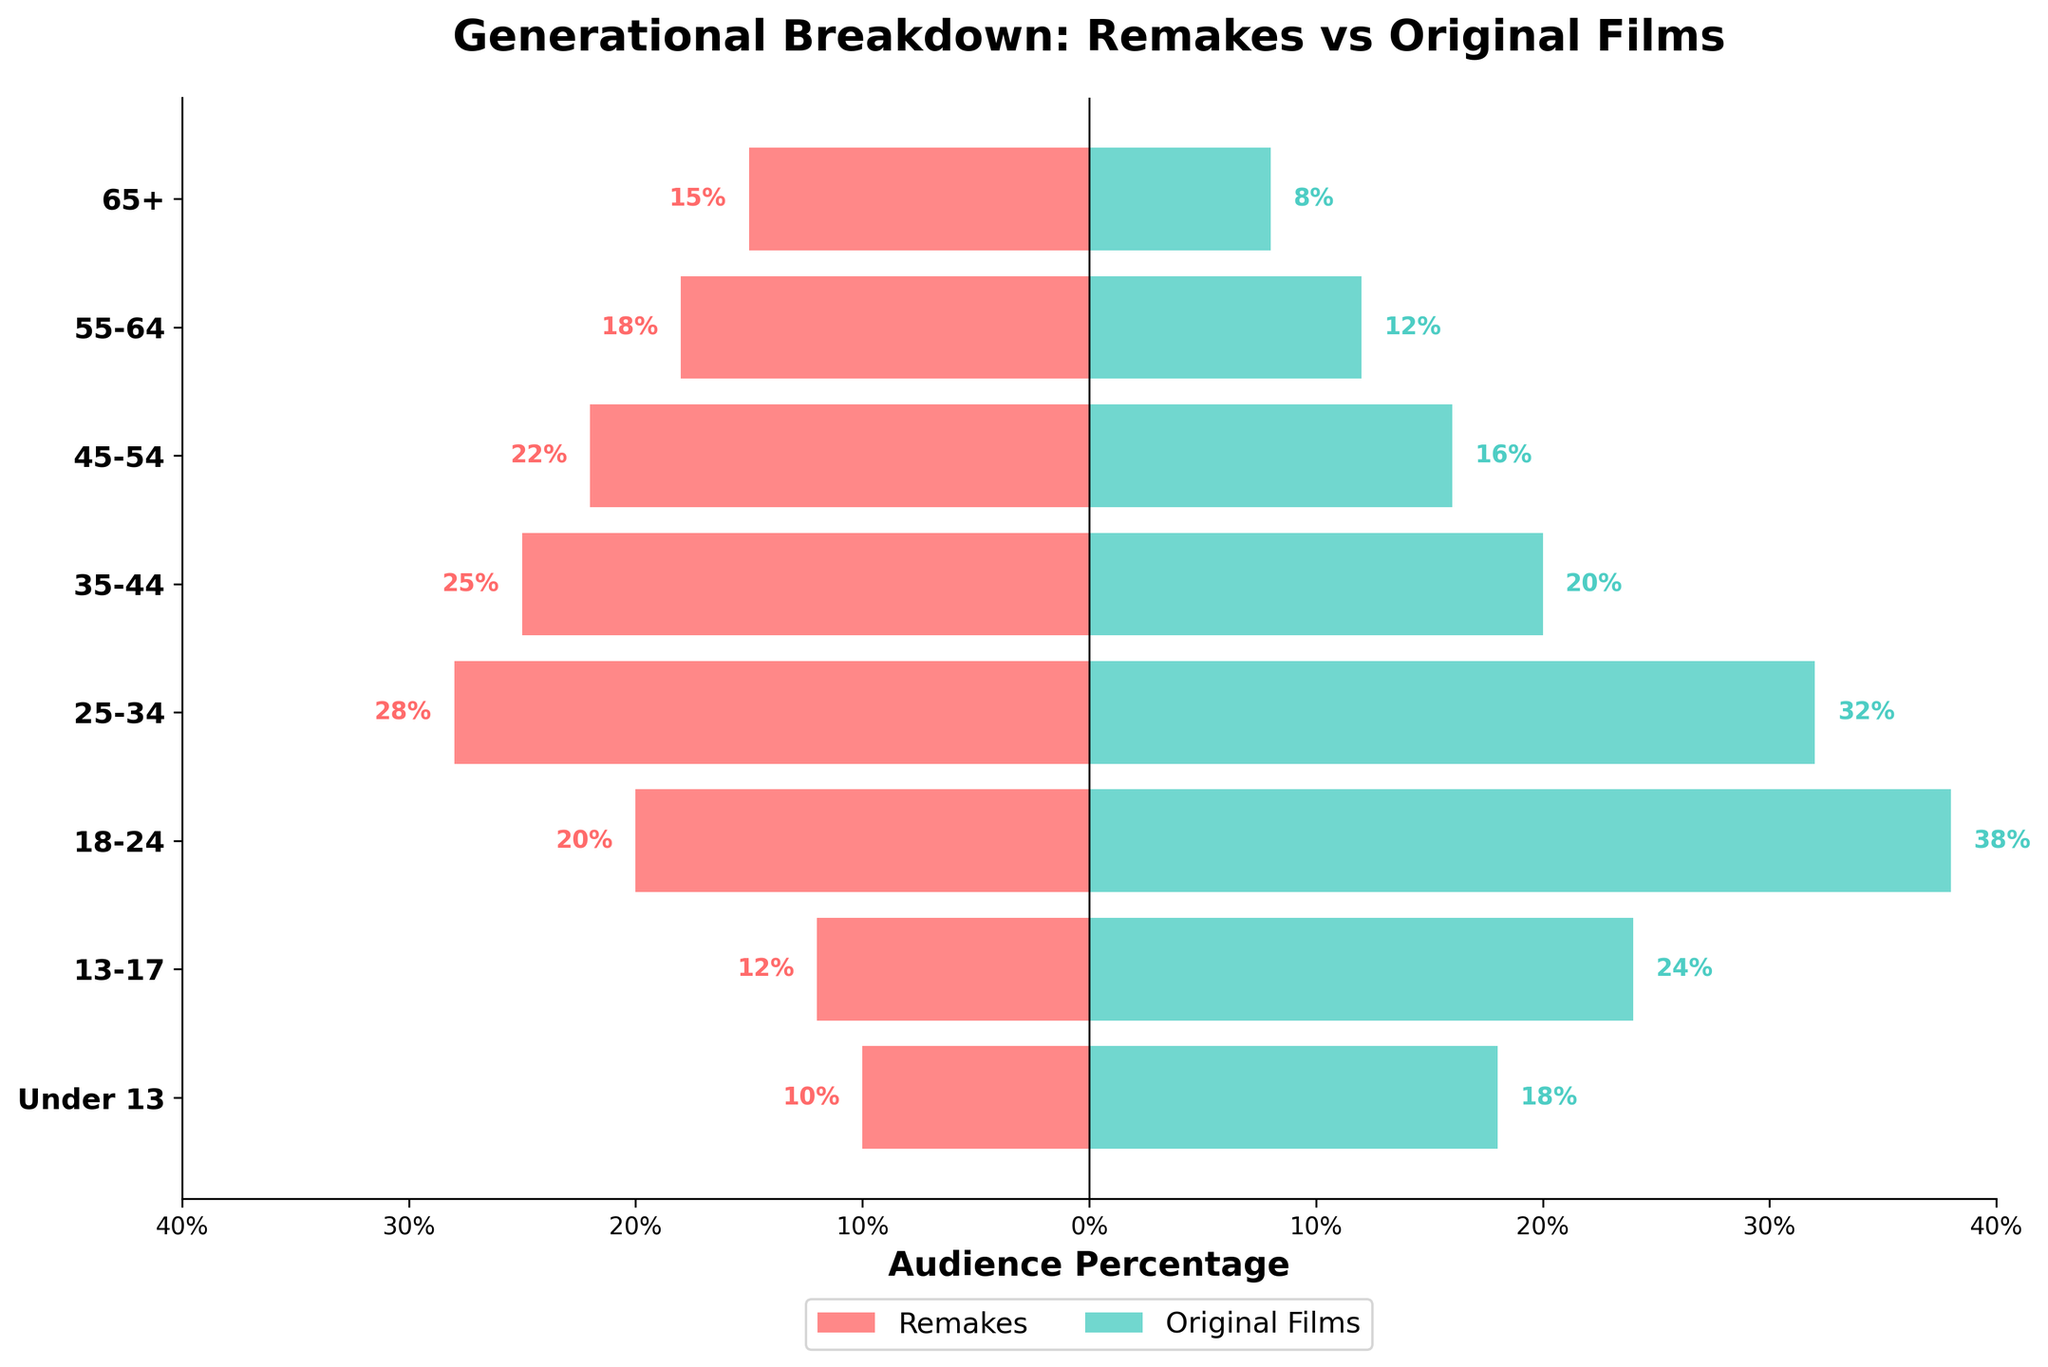Which age group has the highest percentage for original films? The age group with the highest percentage for original films is identified by looking at the longest green bar on the positive side of the chart, which corresponds to the 18-24 age group (38%).
Answer: 18-24 Which age group has the lowest percentage for remakes? The age group with the lowest percentage for remakes is found by identifying the shortest red bar on the negative side of the chart, which corresponds to the 'Under 13' group (10%).
Answer: Under 13 What is the difference in percentages for the 25-34 age group between remakes and original films? For the 25-34 age group, the percentage for remakes is 28%, and for original films, it is 32%. The difference is found by subtracting the two values: 32% - 28% = 4%.
Answer: 4% Does any age group have more viewers for remakes than for original films? To determine if an age group has more viewers for remakes, compare the lengths of the red and green bars in each age group. The chart shows no age group where the red bar (remakes) is longer than the green bar (original films).
Answer: No Which age group has the closest percentages between remakes and original films? The age group with the closest percentages between remakes and original films is found by comparing the relative lengths of the red and green bars. The 35-44 age group has 25% for remakes and 20% for original films, a difference of 5%, which is the smallest such difference on the chart.
Answer: 35-44 Compare the percentage of the 13-17 age group for remakes and original films. The percentage for the 13-17 age group is 12% for remakes and 24% for original films. A comparison shows that the percentage for original films (24%) is double that of remakes (12%).
Answer: Original films: 24%, Remakes: 12% What is the combined percentage of the 45-54 age group for both remakes and original films? To find the combined percentage for the 45-54 age group, sum the percentages of remakes (22%) and original films (16%): 22% + 16% = 38%.
Answer: 38% Which age group has the second-highest number of viewers for original films? The second-highest percentage of viewers for original films is identified by finding the second-longest green bar. The age group 25-34 is the second highest at 32%.
Answer: 25-34 What is the ratio of the percentage of viewers aged 55-64 for remakes to original films? The percentages for the 55-64 age group are 18% for remakes and 12% for original films. The ratio is calculated as 18/12 or 3:2.
Answer: 3:2 How many age groups have a higher percentage of viewers for original films compared to remakes? By examining the chart, we can count that all age groups have a higher percentage of viewers for original films compared to remakes, totaling 8 age groups.
Answer: 8 